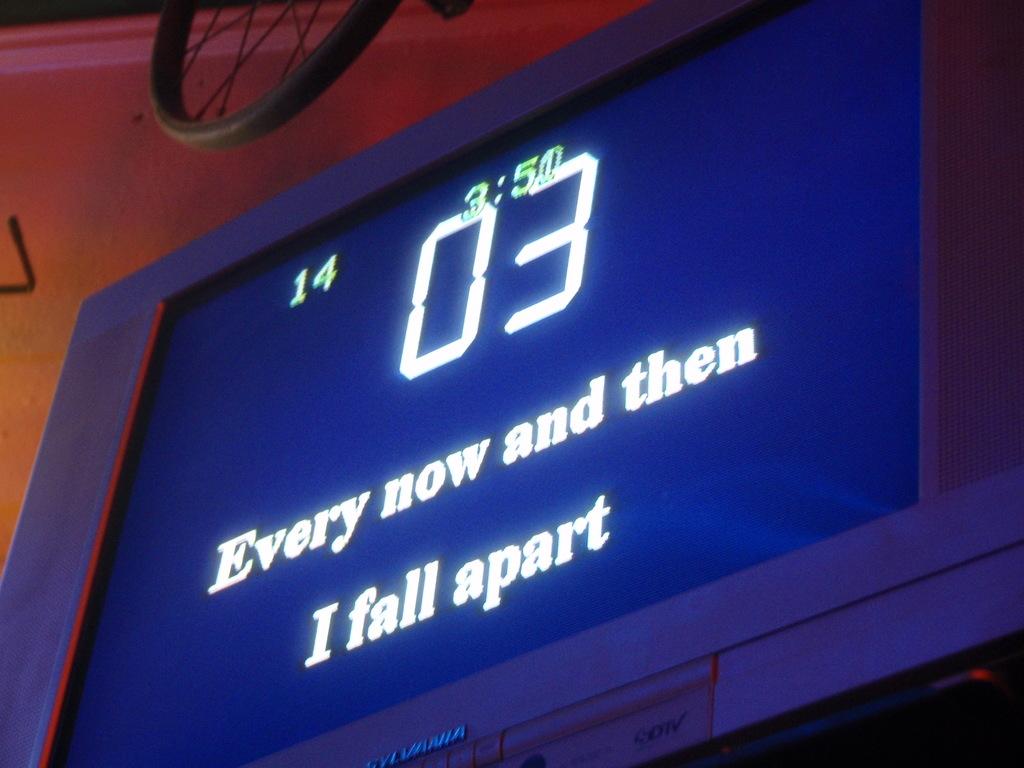Every now and then, what happens?
Ensure brevity in your answer.  I fall apart. What time is it on the sing?
Your response must be concise. 3:50. 